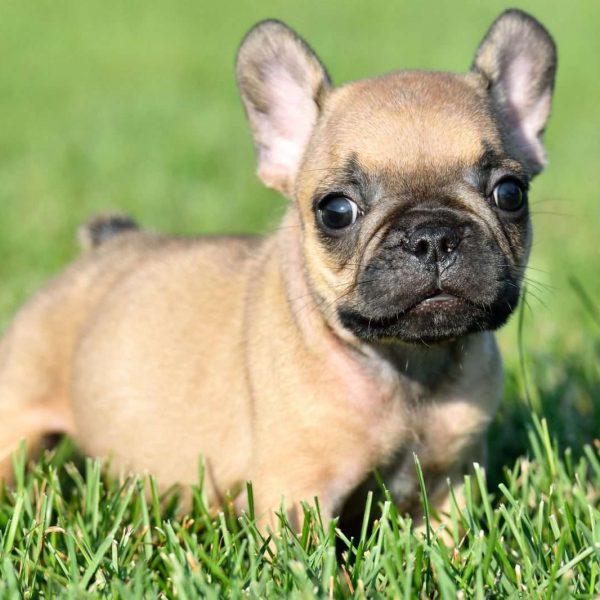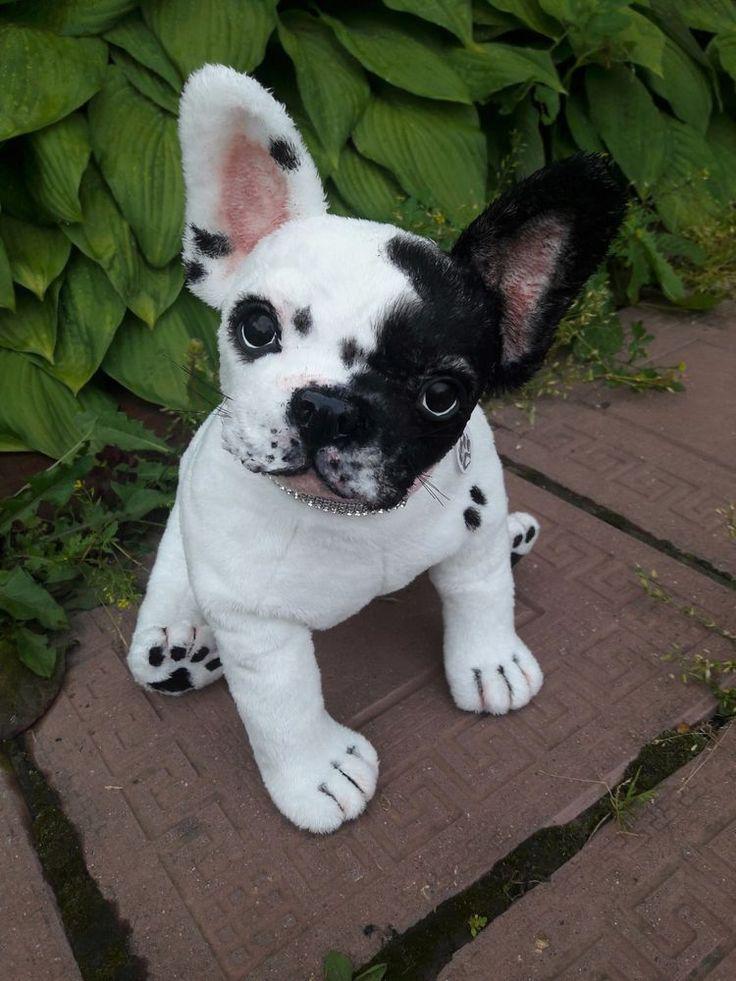The first image is the image on the left, the second image is the image on the right. Assess this claim about the two images: "There is a bulldog with a small white patch of fur on his chest and all four of his feet are in the grass.". Correct or not? Answer yes or no. No. The first image is the image on the left, the second image is the image on the right. Analyze the images presented: Is the assertion "Left image shows one tan-colored dog posed in the grass, with body turned rightward." valid? Answer yes or no. Yes. 